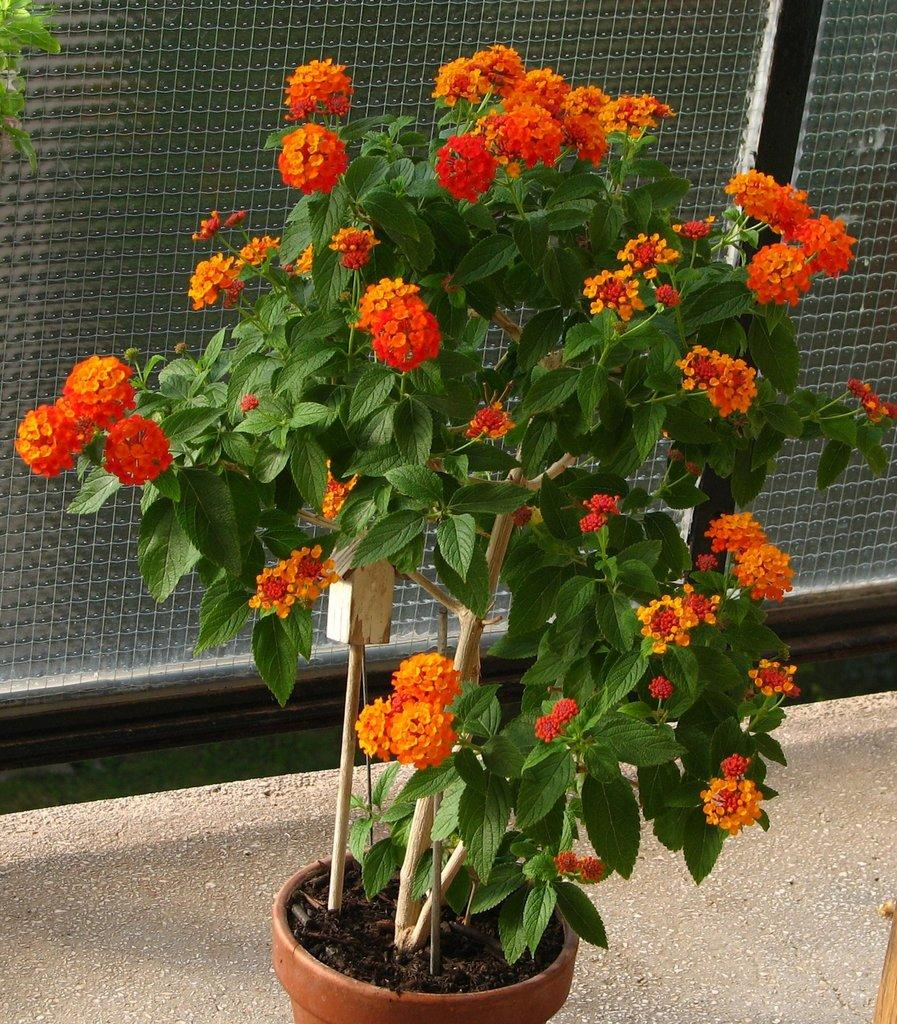What is the main subject in the center of the image? There is a flower plant in the center of the image. What can be seen at the bottom of the image? There is a road at the bottom of the image. What type of fencing is visible in the background of the image? There is glass fencing in the background of the image. What type of competition is taking place in the image? There is no competition present in the image; it features a flower plant, a road, and glass fencing. Can you see any cannons or signs of war in the image? There are no cannons or signs of war present in the image. 